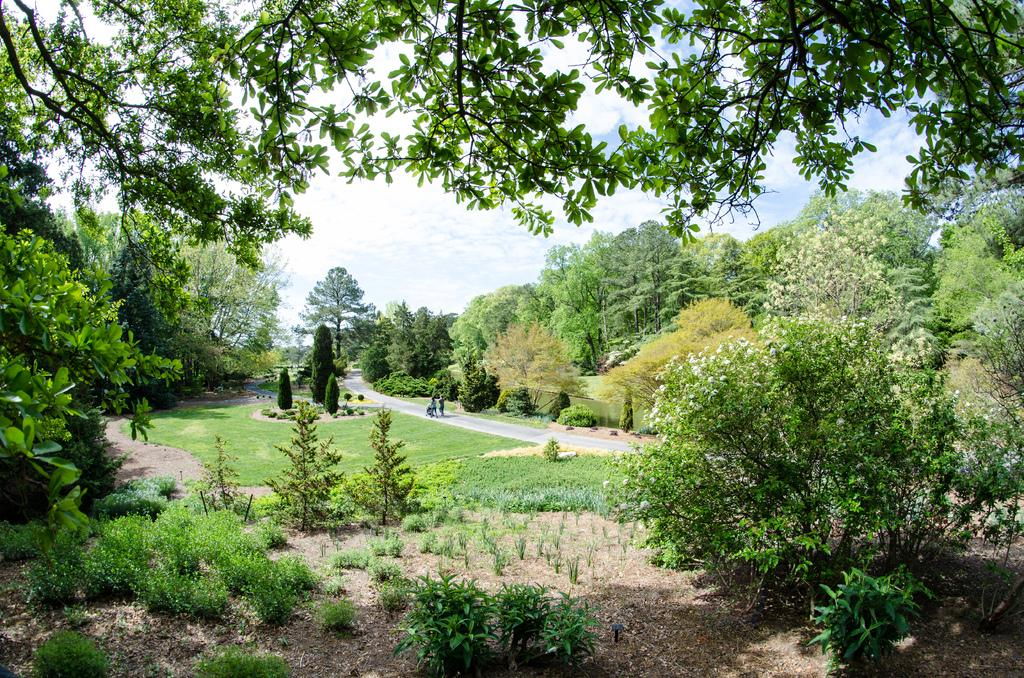What type of vegetation can be seen in the image? There are many trees and plants in the image. What can be seen on the ground in the image? The ground is visible in the image, and there is grass present. What type of pathway is in the image? There is a road in the image. What is visible in the background of the image? The sky is visible in the background of the image. What else can be seen in the middle of the image? There are people in the middle of the image. Where is the scarecrow located in the image? There is no scarecrow present in the image. What type of bag is being carried by the people in the image? There is no bag visible in the image; only people are present. 